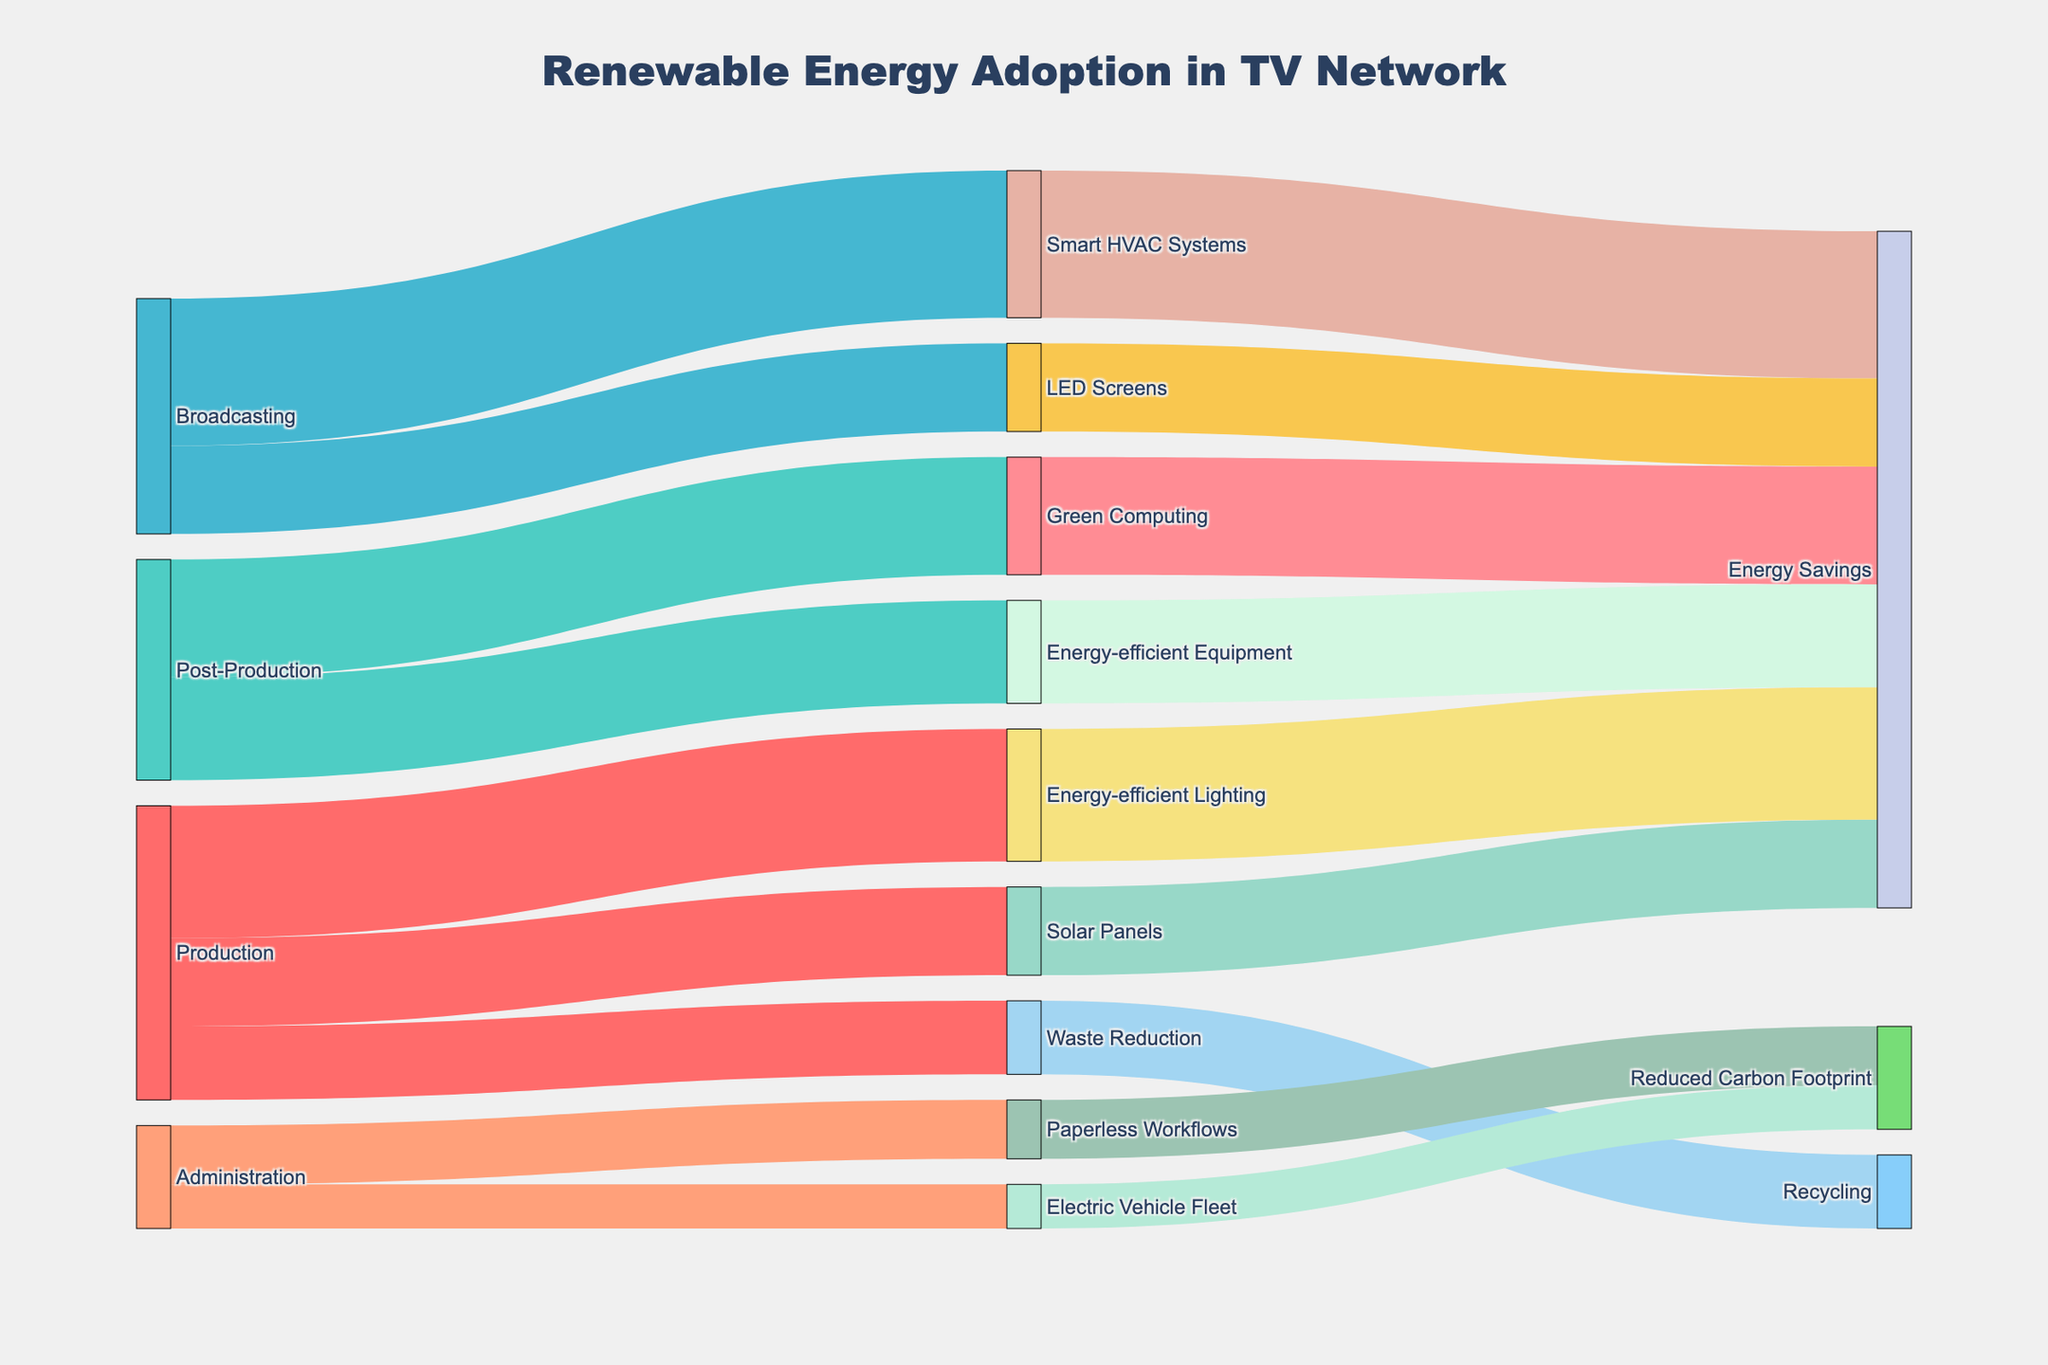What is the total value for renewable energy practices adopted by the Production department? Sum the values associated with the Production department: 30 (Solar Panels) + 45 (Energy-efficient Lighting) + 25 (Waste Reduction). 30 + 45 + 25 = 100
Answer: 100 Which department contributes the most to Energy Savings? Based on the target nodes for "Energy Savings", we have: Production (Solar Panels: 30 + Energy-efficient Lighting: 45), Post-Production (Green Computing: 40 + Energy-efficient Equipment: 35), and Broadcasting (Smart HVAC Systems: 50 + LED Screens: 30). Thus, the values are 75, 75, and 80 respectively. Broadcasting (80) contributes the most.
Answer: Broadcasting How does the value for Paperless Workflows in Administration compare to Green Computing in Post-Production? Compare the values: Paperless Workflows (20) and Green Computing (40). 20 < 40
Answer: Paperless Workflows has a lower value What's the combined value of waste reduction and recycling-related practices? Sum the values associated with Waste Reduction and Recycling: 25 (Waste Reduction) + 25 (Recycling). 25 + 25 = 50
Answer: 50 What is the primary outcome for Energy-efficient Lighting? Trace the flow from Energy-efficient Lighting (Production) to its main target, which is Energy Savings (45).
Answer: Energy Savings Which department shows the least adoption of renewable energy practices? Compare total values across departments. Administration has values 20 (Paperless Workflows) + 15 (Electric Vehicle Fleet) = 35, which is the lowest.
Answer: Administration What are the adoption rates of Energy-efficient Equipment in Post-Production and Electric Vehicle Fleet in Administration? Identify the values directly from the nodes: Energy-efficient Equipment (35), Electric Vehicle Fleet (15).
Answer: Energy-efficient Equipment: 35, Electric Vehicle Fleet: 15 Which practice has the highest single adoption rate? Identify the maximum value from all practices: Smart HVAC Systems (50).
Answer: Smart HVAC Systems Is the value for Waste Reduction higher than that for Paperless Workflows? Compare the values: Waste Reduction (25) and Paperless Workflows (20). 25 > 20
Answer: Yes What is the sum of values for all practices adopted in Broadcasting? Sum the values associated with Broadcasting: Smart HVAC Systems (50) + LED Screens (30). 50 + 30 = 80
Answer: 80 